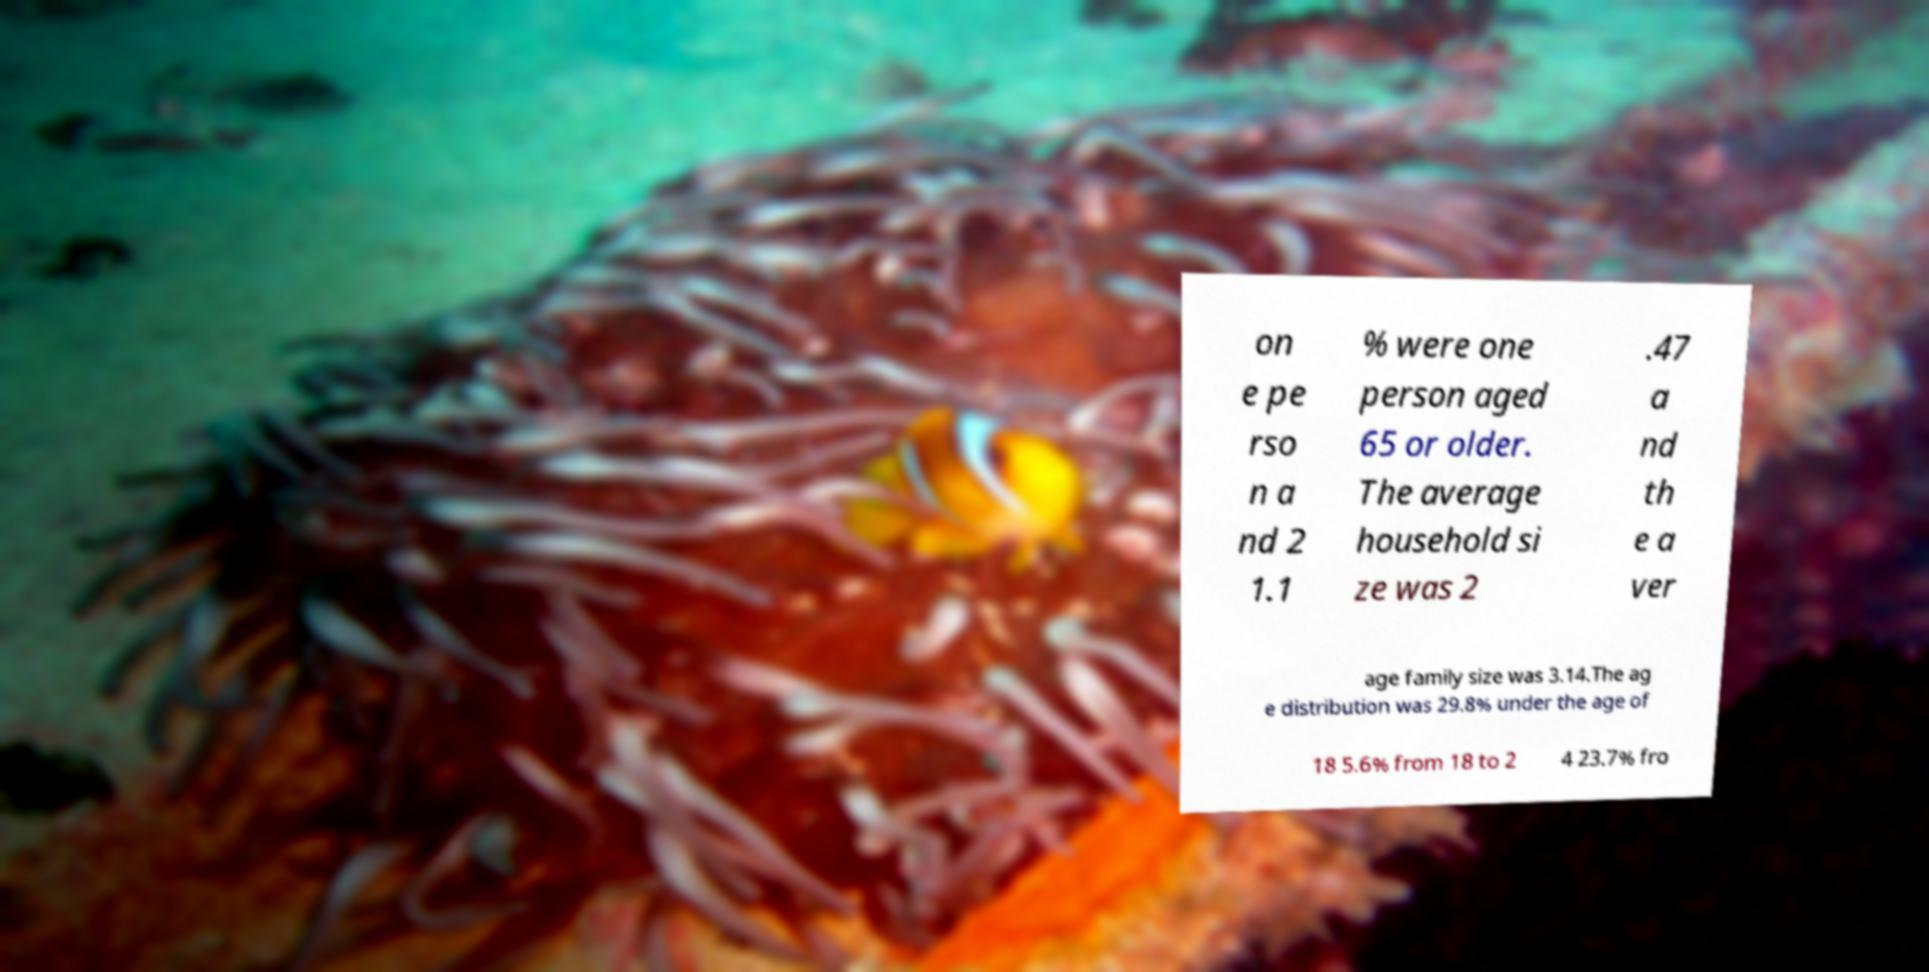Please identify and transcribe the text found in this image. on e pe rso n a nd 2 1.1 % were one person aged 65 or older. The average household si ze was 2 .47 a nd th e a ver age family size was 3.14.The ag e distribution was 29.8% under the age of 18 5.6% from 18 to 2 4 23.7% fro 